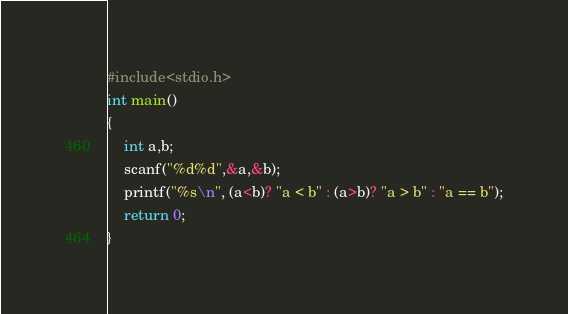Convert code to text. <code><loc_0><loc_0><loc_500><loc_500><_C_>#include<stdio.h>
int main()
{
	int a,b;
	scanf("%d%d",&a,&b);
	printf("%s\n", (a<b)? "a < b" : (a>b)? "a > b" : "a == b");
	return 0;
}</code> 